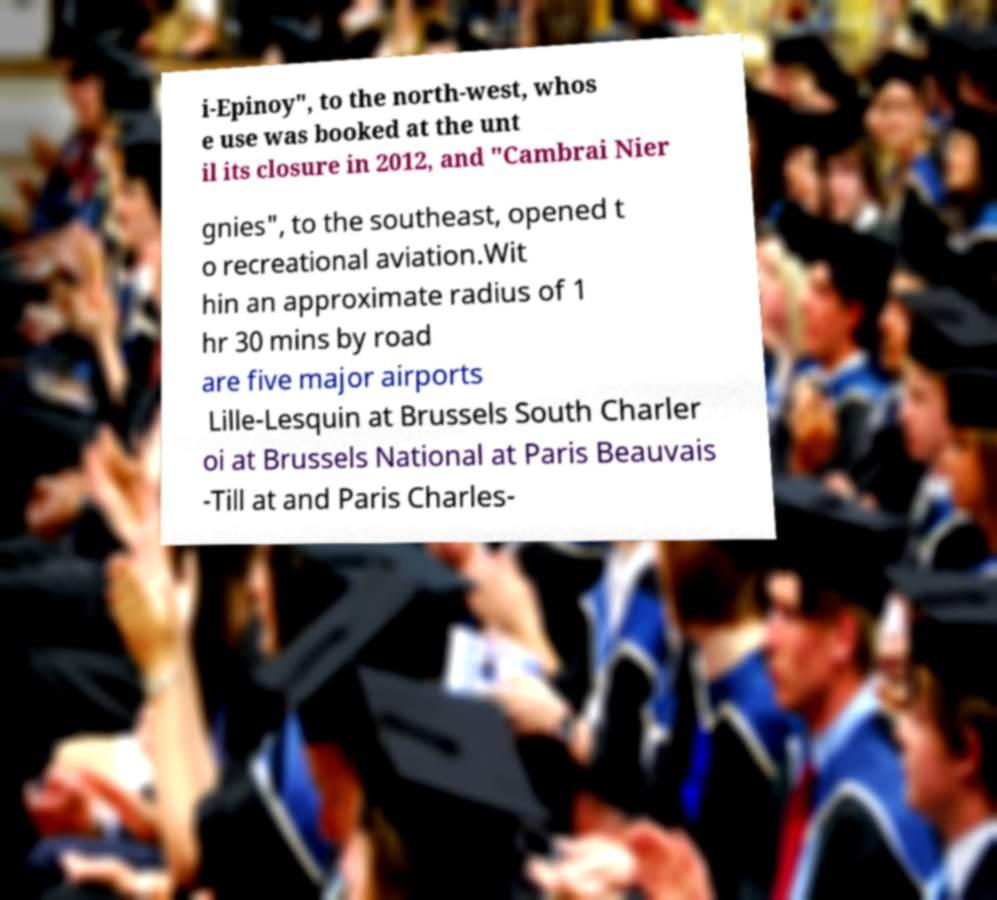There's text embedded in this image that I need extracted. Can you transcribe it verbatim? i-Epinoy", to the north-west, whos e use was booked at the unt il its closure in 2012, and "Cambrai Nier gnies", to the southeast, opened t o recreational aviation.Wit hin an approximate radius of 1 hr 30 mins by road are five major airports Lille-Lesquin at Brussels South Charler oi at Brussels National at Paris Beauvais -Till at and Paris Charles- 